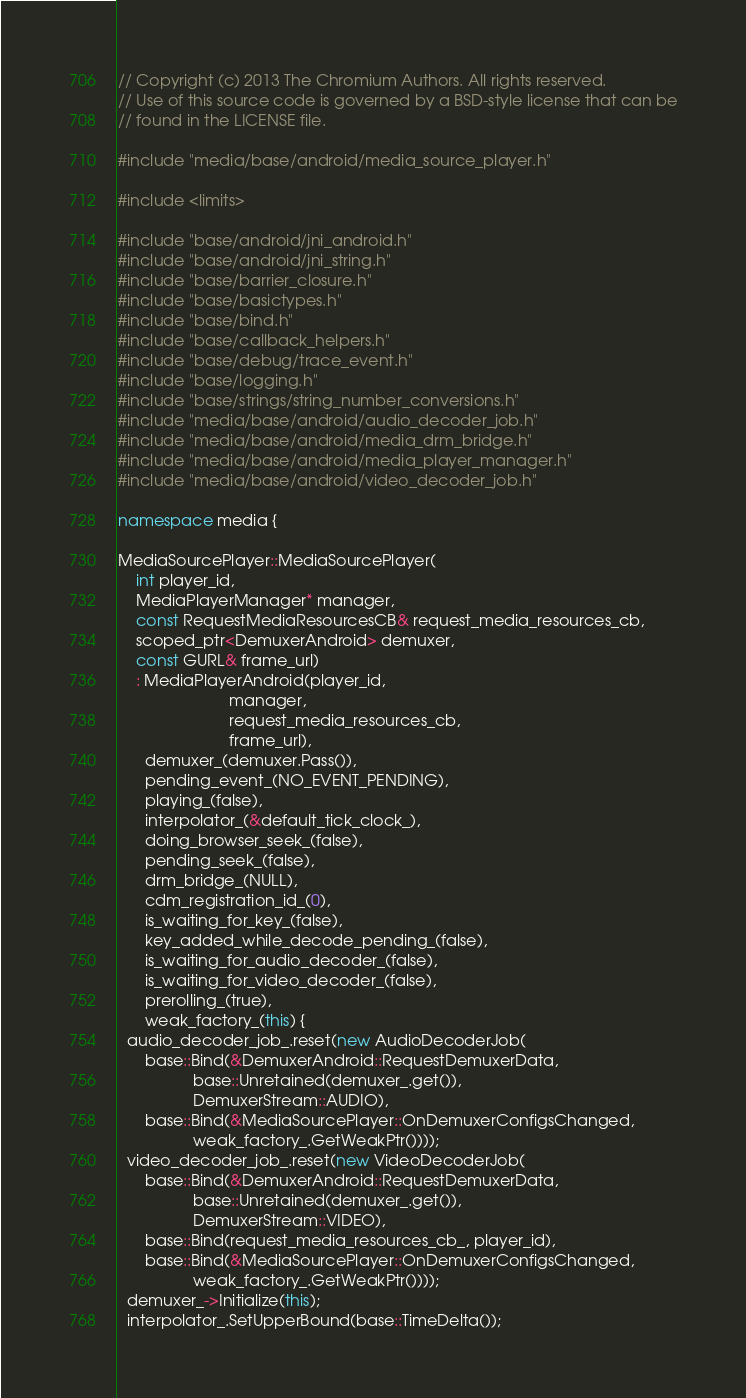Convert code to text. <code><loc_0><loc_0><loc_500><loc_500><_C++_>// Copyright (c) 2013 The Chromium Authors. All rights reserved.
// Use of this source code is governed by a BSD-style license that can be
// found in the LICENSE file.

#include "media/base/android/media_source_player.h"

#include <limits>

#include "base/android/jni_android.h"
#include "base/android/jni_string.h"
#include "base/barrier_closure.h"
#include "base/basictypes.h"
#include "base/bind.h"
#include "base/callback_helpers.h"
#include "base/debug/trace_event.h"
#include "base/logging.h"
#include "base/strings/string_number_conversions.h"
#include "media/base/android/audio_decoder_job.h"
#include "media/base/android/media_drm_bridge.h"
#include "media/base/android/media_player_manager.h"
#include "media/base/android/video_decoder_job.h"

namespace media {

MediaSourcePlayer::MediaSourcePlayer(
    int player_id,
    MediaPlayerManager* manager,
    const RequestMediaResourcesCB& request_media_resources_cb,
    scoped_ptr<DemuxerAndroid> demuxer,
    const GURL& frame_url)
    : MediaPlayerAndroid(player_id,
                         manager,
                         request_media_resources_cb,
                         frame_url),
      demuxer_(demuxer.Pass()),
      pending_event_(NO_EVENT_PENDING),
      playing_(false),
      interpolator_(&default_tick_clock_),
      doing_browser_seek_(false),
      pending_seek_(false),
      drm_bridge_(NULL),
      cdm_registration_id_(0),
      is_waiting_for_key_(false),
      key_added_while_decode_pending_(false),
      is_waiting_for_audio_decoder_(false),
      is_waiting_for_video_decoder_(false),
      prerolling_(true),
      weak_factory_(this) {
  audio_decoder_job_.reset(new AudioDecoderJob(
      base::Bind(&DemuxerAndroid::RequestDemuxerData,
                 base::Unretained(demuxer_.get()),
                 DemuxerStream::AUDIO),
      base::Bind(&MediaSourcePlayer::OnDemuxerConfigsChanged,
                 weak_factory_.GetWeakPtr())));
  video_decoder_job_.reset(new VideoDecoderJob(
      base::Bind(&DemuxerAndroid::RequestDemuxerData,
                 base::Unretained(demuxer_.get()),
                 DemuxerStream::VIDEO),
      base::Bind(request_media_resources_cb_, player_id),
      base::Bind(&MediaSourcePlayer::OnDemuxerConfigsChanged,
                 weak_factory_.GetWeakPtr())));
  demuxer_->Initialize(this);
  interpolator_.SetUpperBound(base::TimeDelta());</code> 